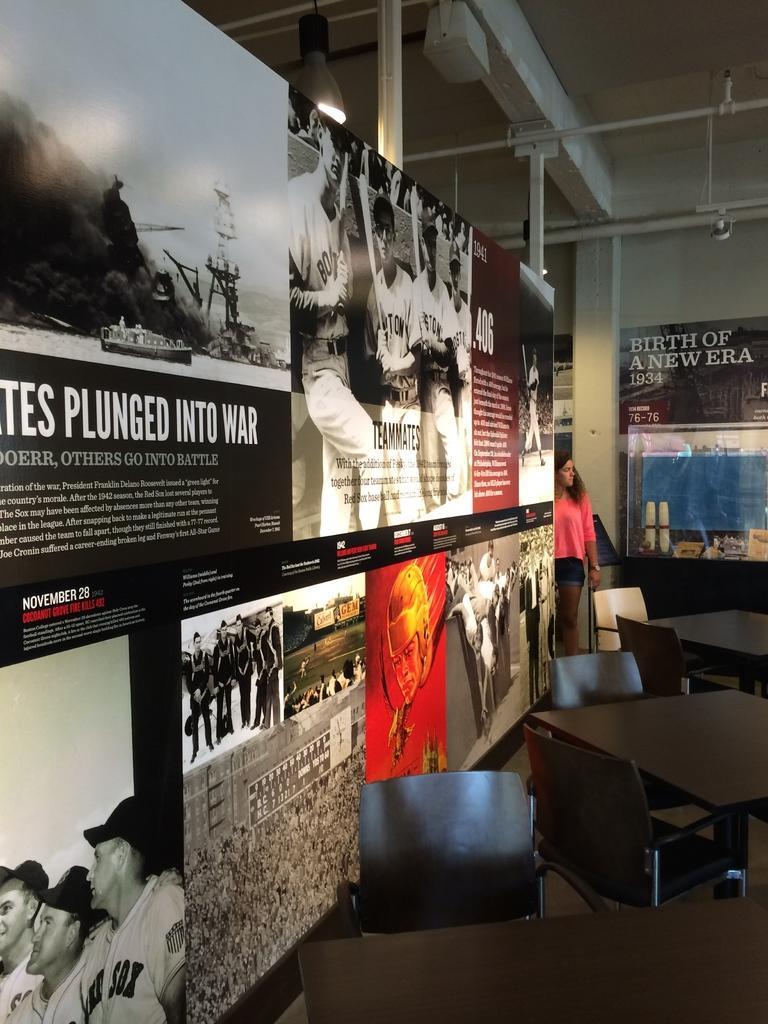Please provide a concise description of this image. On the left we can see a hoarding and a woman. beside this hoarding there are tables and chairs. In the background we can see wall,poles and a hoarding. 